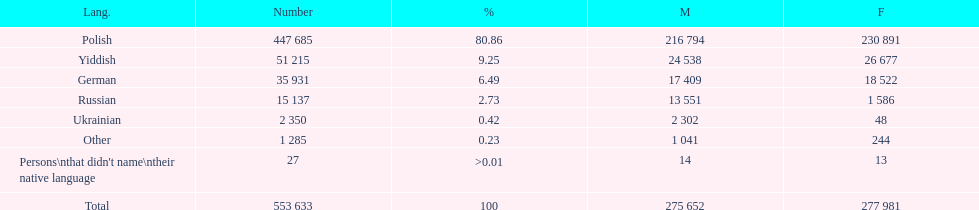How many male and female german speakers are there? 35931. 